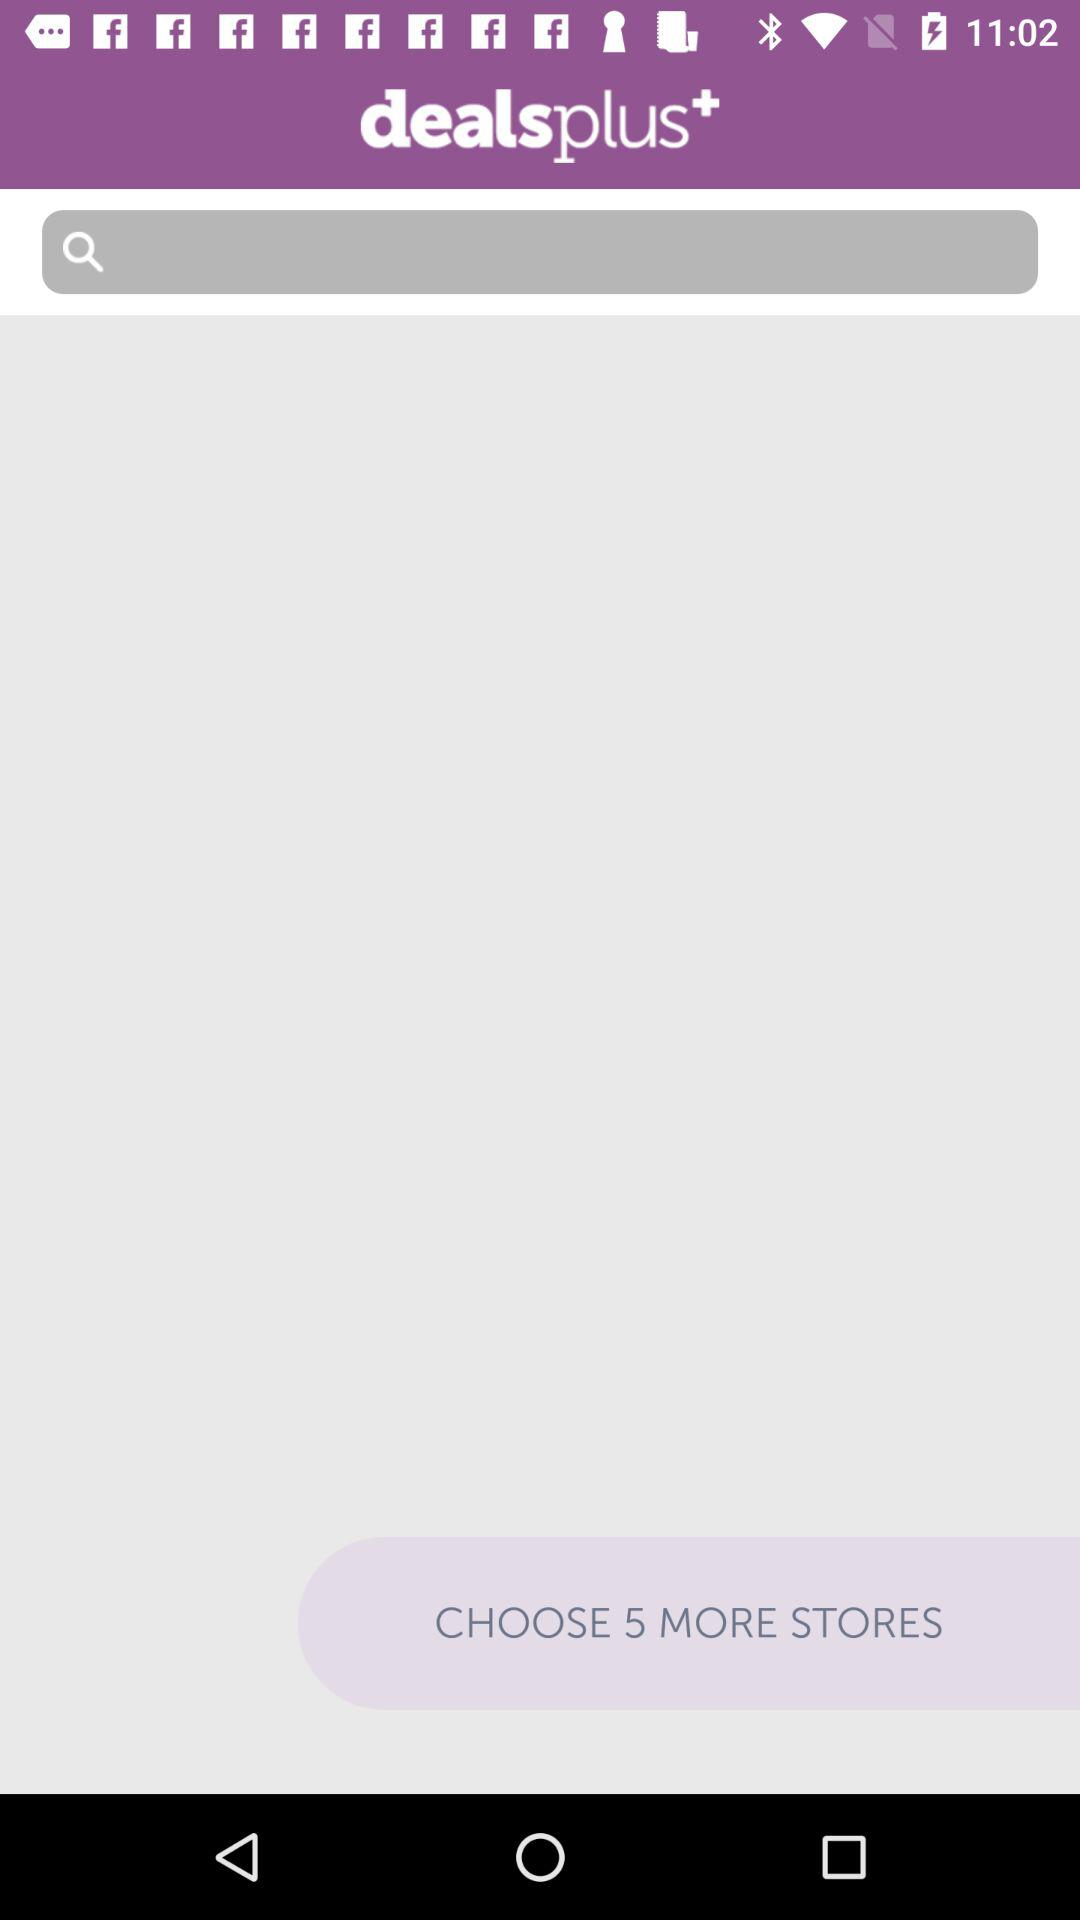What is the application name? The application name is "dealsplus+". 